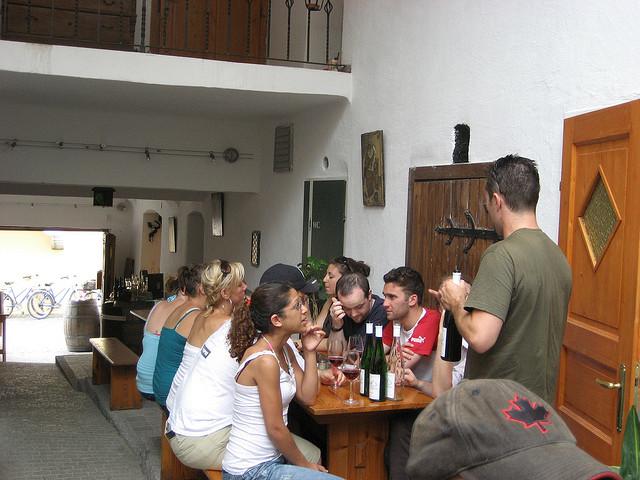What number of boards make up the bench?
Give a very brief answer. 1. What are they doing?
Give a very brief answer. Eating. Are these people eating any food?
Write a very short answer. No. Is this a market?
Answer briefly. No. What is parked just outside of the door?
Keep it brief. Bicycles. 